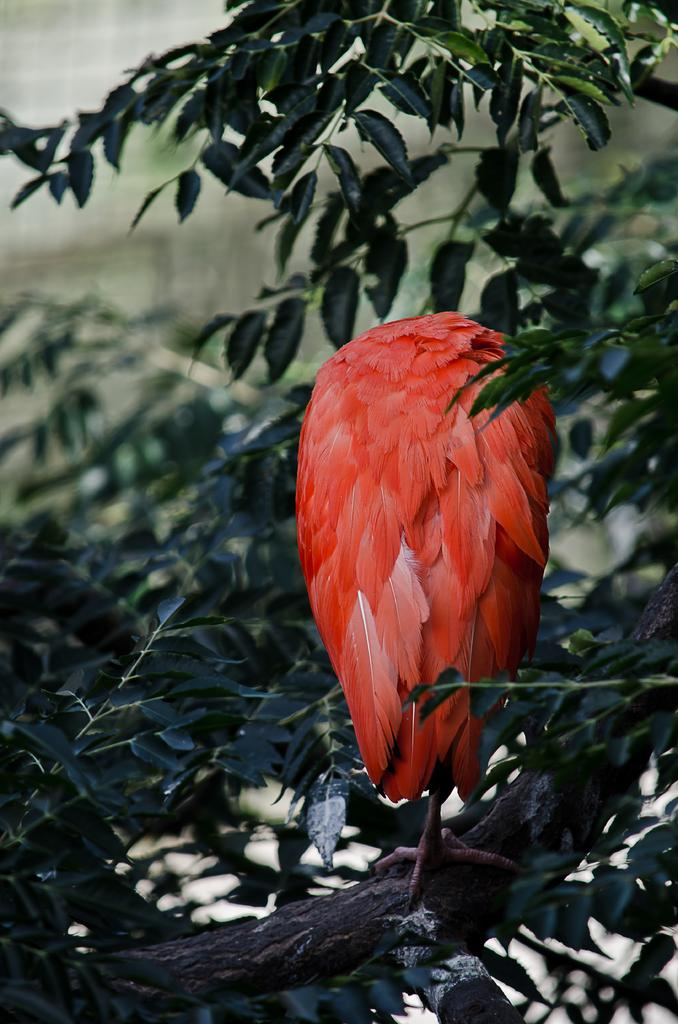What is present in the image? There is a plant in the image. What is on the plant? There is a bird on the plant. Can you describe the bird's appearance? The bird has some orange color features. What type of cup is the bird using to trade with the drum in the image? There is no cup, trade, or drum present in the image. 